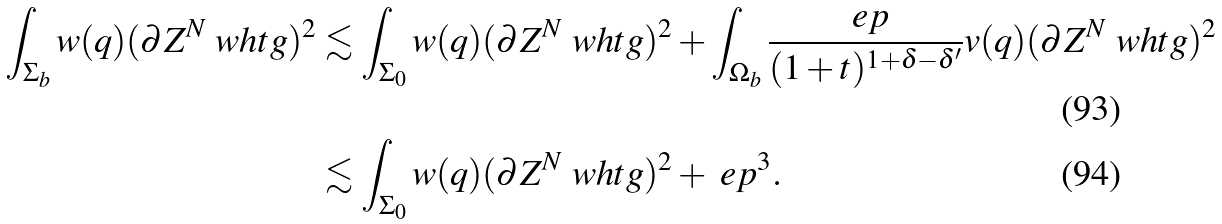<formula> <loc_0><loc_0><loc_500><loc_500>\int _ { \Sigma _ { b } } w ( q ) ( \partial Z ^ { N } \ w h t g ) ^ { 2 } & \lesssim \int _ { \Sigma _ { 0 } } w ( q ) ( \partial Z ^ { N } \ w h t g ) ^ { 2 } + \int _ { \Omega _ { b } } \frac { \ e p } { ( 1 + t ) ^ { 1 + \delta - \delta ^ { \prime } } } v ( q ) ( \partial Z ^ { N } \ w h t g ) ^ { 2 } \\ & \lesssim \int _ { \Sigma _ { 0 } } w ( q ) ( \partial Z ^ { N } \ w h t g ) ^ { 2 } + \ e p ^ { 3 } .</formula> 